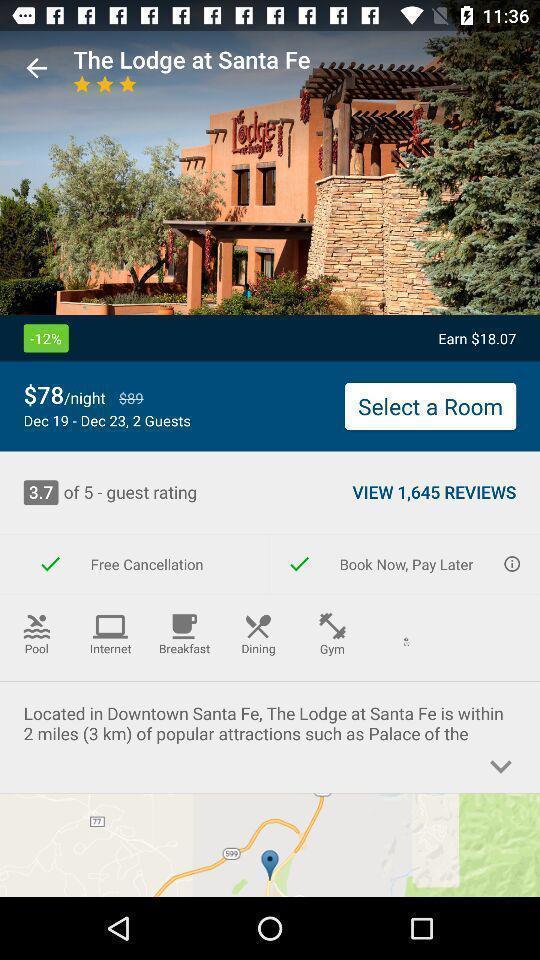Tell me what you see in this picture. Screen shows location of hotel. 